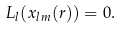Convert formula to latex. <formula><loc_0><loc_0><loc_500><loc_500>L _ { l } ( x _ { l m } ( r ) ) = 0 .</formula> 